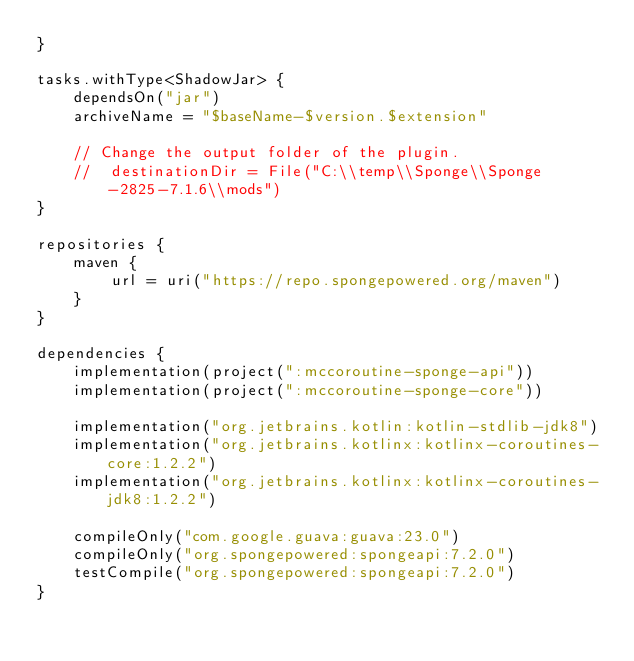Convert code to text. <code><loc_0><loc_0><loc_500><loc_500><_Kotlin_>}

tasks.withType<ShadowJar> {
    dependsOn("jar")
    archiveName = "$baseName-$version.$extension"

    // Change the output folder of the plugin.
    //  destinationDir = File("C:\\temp\\Sponge\\Sponge-2825-7.1.6\\mods")
}

repositories {
    maven {
        url = uri("https://repo.spongepowered.org/maven")
    }
}

dependencies {
    implementation(project(":mccoroutine-sponge-api"))
    implementation(project(":mccoroutine-sponge-core"))

    implementation("org.jetbrains.kotlin:kotlin-stdlib-jdk8")
    implementation("org.jetbrains.kotlinx:kotlinx-coroutines-core:1.2.2")
    implementation("org.jetbrains.kotlinx:kotlinx-coroutines-jdk8:1.2.2")

    compileOnly("com.google.guava:guava:23.0")
    compileOnly("org.spongepowered:spongeapi:7.2.0")
    testCompile("org.spongepowered:spongeapi:7.2.0")
}
</code> 